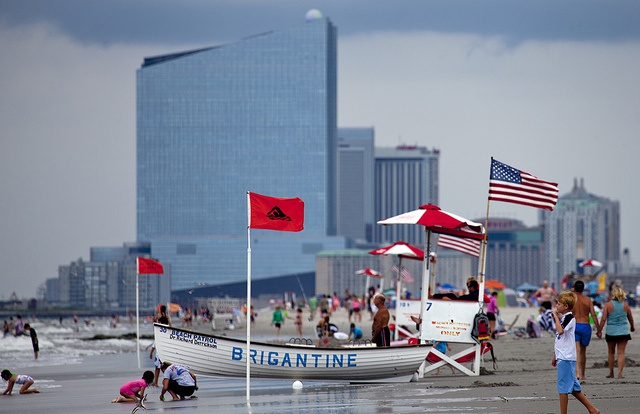Describe the objects in this image and their specific colors. I can see boat in gray, darkgray, lightgray, and black tones, people in gray, darkgray, and black tones, people in gray, blue, maroon, darkgray, and black tones, people in gray, black, maroon, and blue tones, and people in gray, maroon, black, navy, and brown tones in this image. 